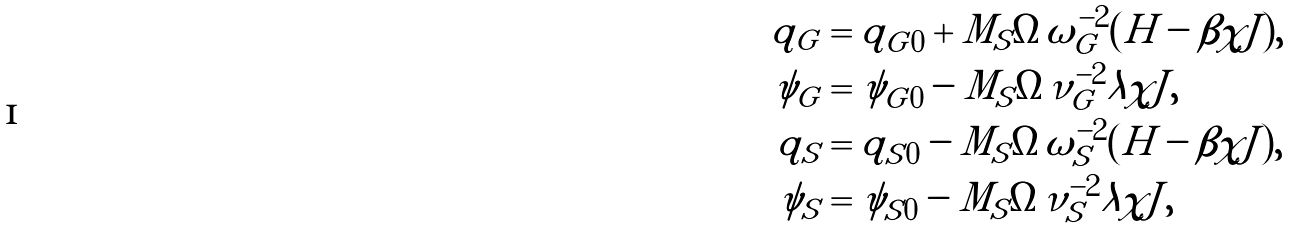Convert formula to latex. <formula><loc_0><loc_0><loc_500><loc_500>q _ { G } & = q _ { G 0 } + { M _ { S } \Omega } { \omega _ { G } ^ { - 2 } } ( H - \beta \chi J ) , \\ \psi _ { G } & = \psi _ { G 0 } - { M _ { S } \Omega } { \nu _ { G } ^ { - 2 } } \lambda \chi J , \\ q _ { S } & = q _ { S 0 } - { M _ { S } \Omega } { \omega _ { S } ^ { - 2 } } ( H - \beta \chi J ) , \\ \psi _ { S } & = \psi _ { S 0 } - { M _ { S } \Omega } { \nu _ { S } ^ { - 2 } } \lambda \chi J ,</formula> 